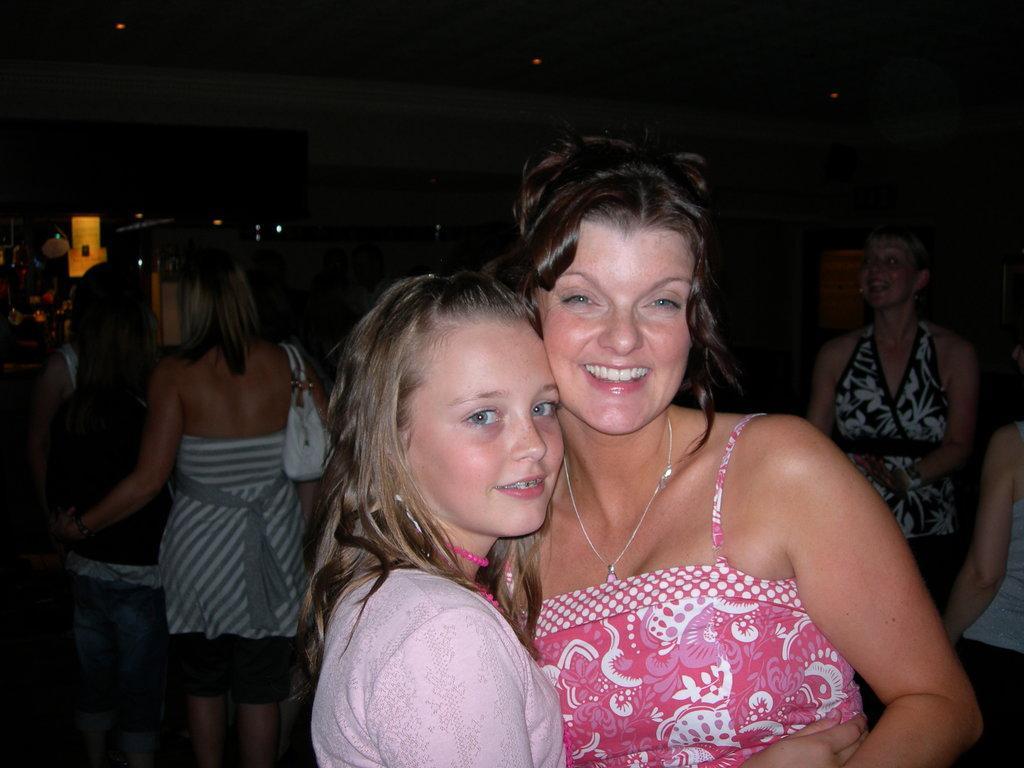How would you summarize this image in a sentence or two? In this image we can see the ladies. In the background of the image there are some persons, wall and other objects. At the top of the image there is the ceiling with lights. 